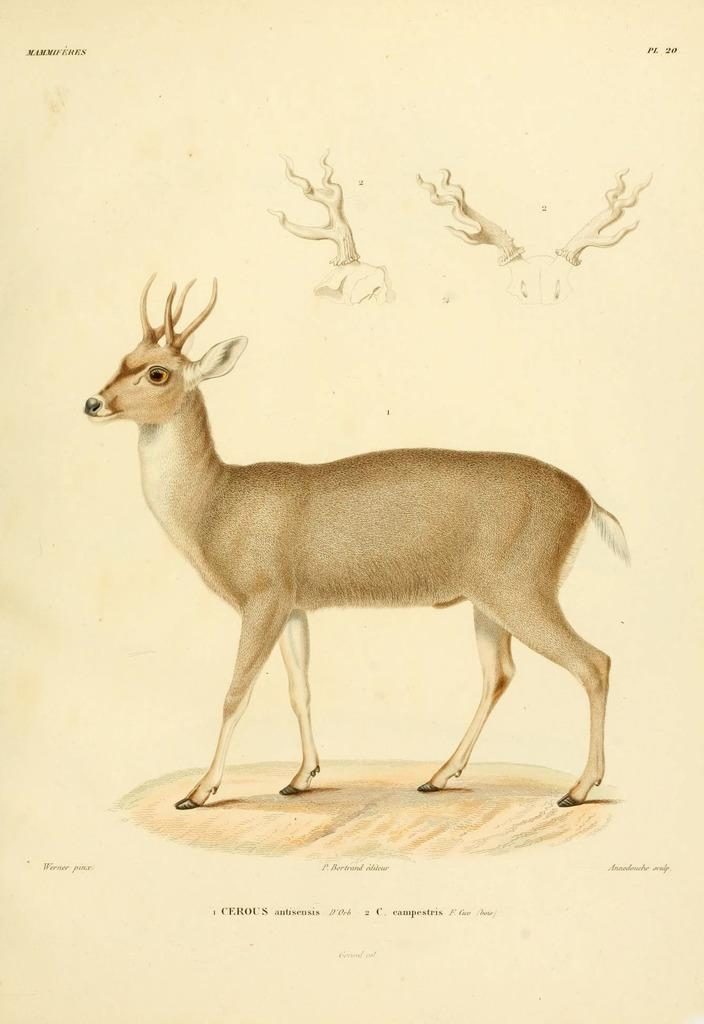What animal is in the center of the image? There is a deer in the center of the image. What distinguishing feature does the deer have? The deer has horns. Is there any text present in the image? Yes, there is some text at the bottom of the image. What type of sock is the turkey wearing in the image? There is no turkey or sock present in the image; it features a deer with horns and some text at the bottom. 